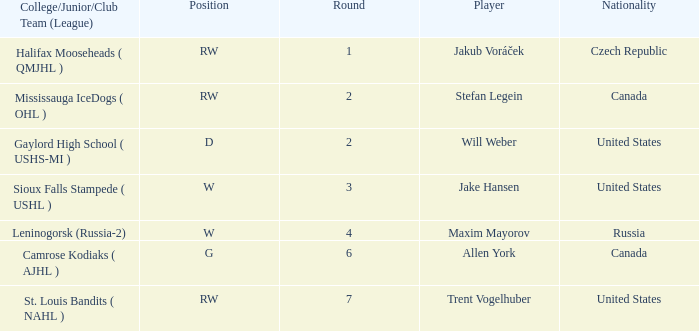What nationality is the draft pick with w position from leninogorsk (russia-2)? Russia. 